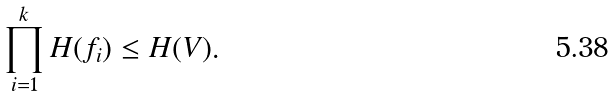Convert formula to latex. <formula><loc_0><loc_0><loc_500><loc_500>\prod _ { i = 1 } ^ { k } H ( f _ { i } ) \leq H ( V ) .</formula> 